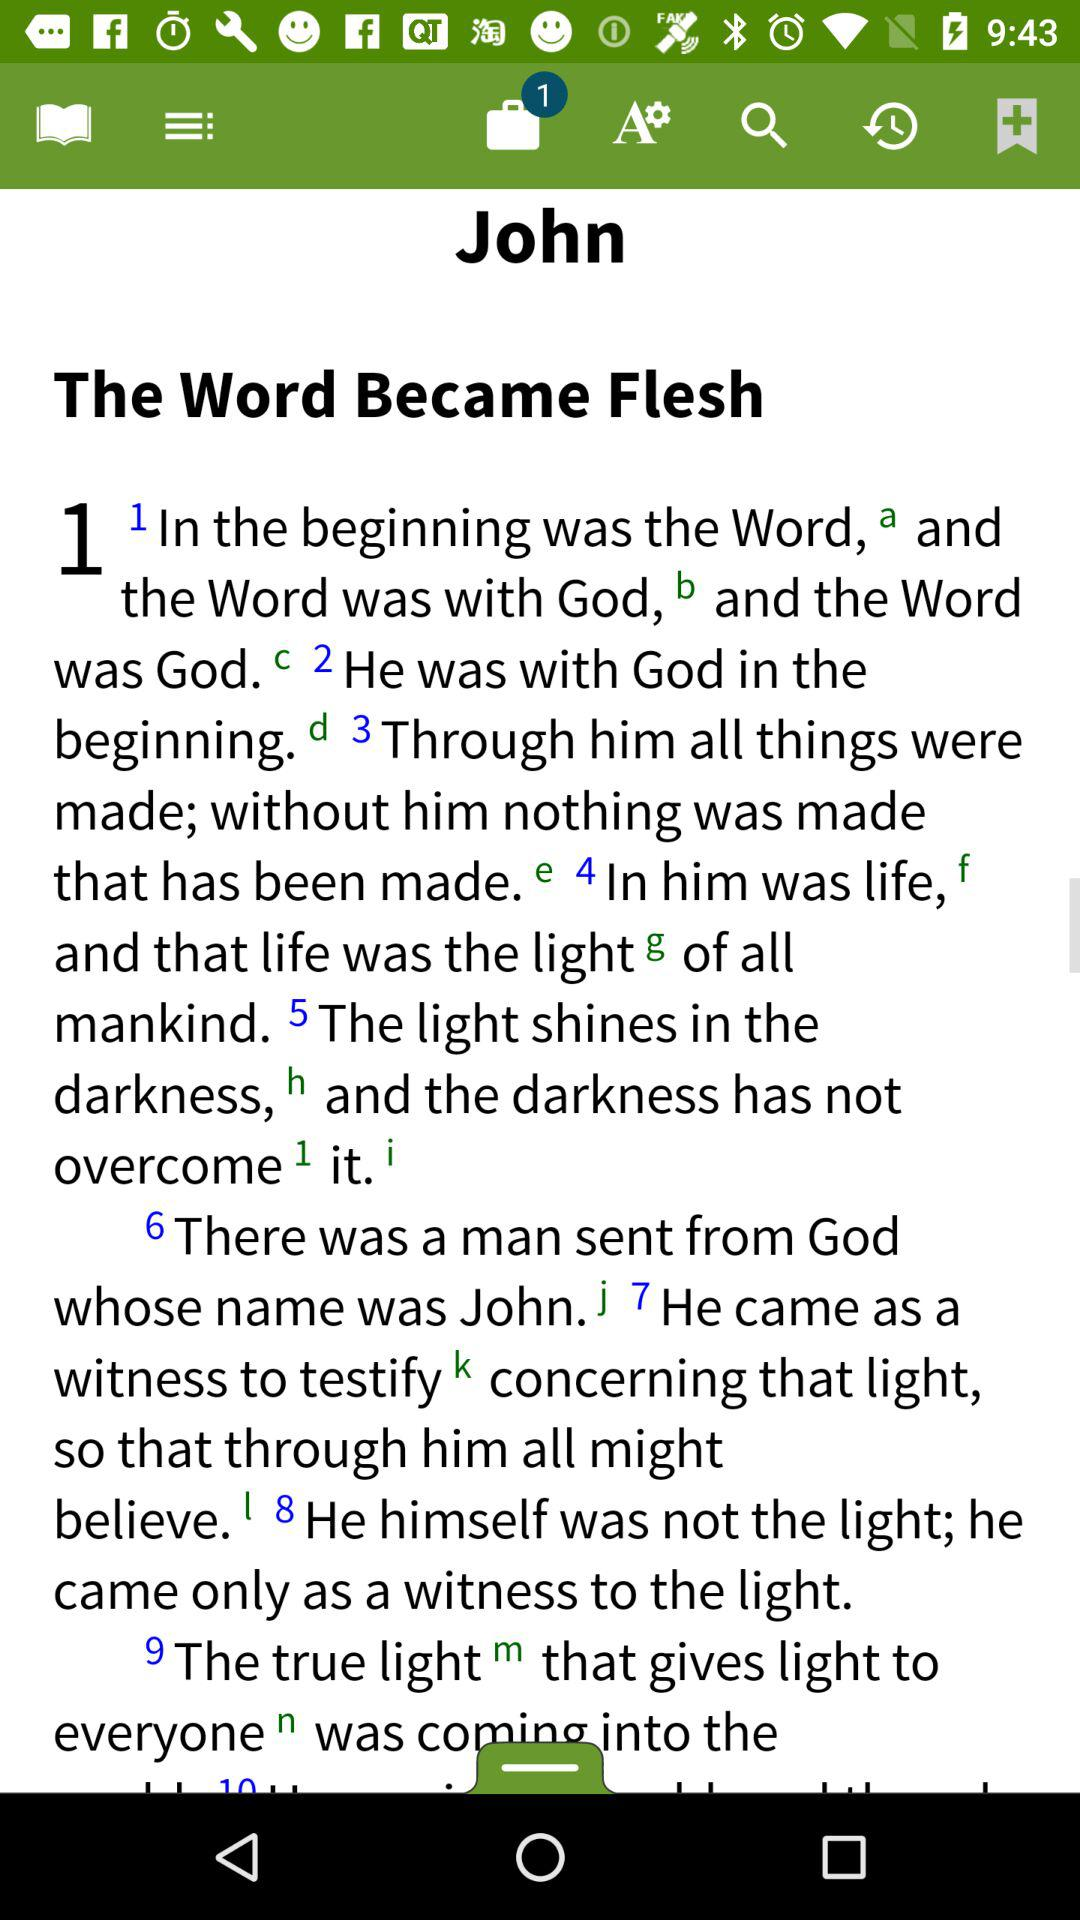What is the user name? The user name is John. 